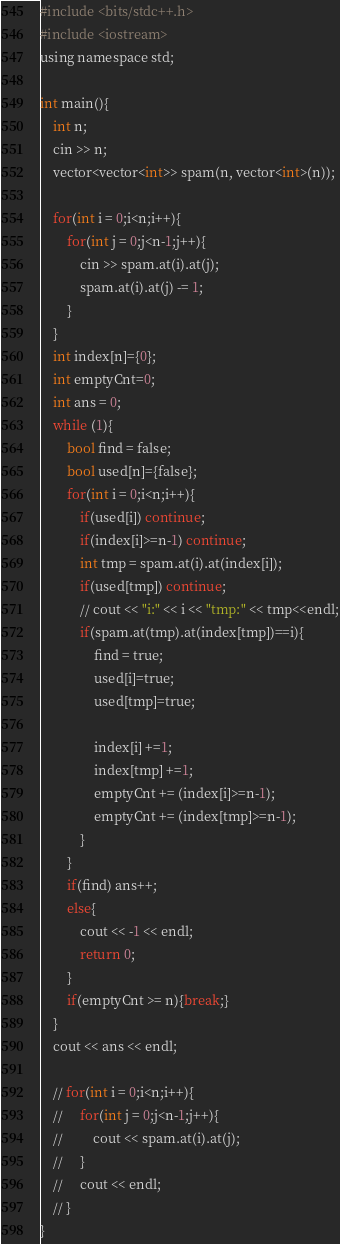<code> <loc_0><loc_0><loc_500><loc_500><_Python_>#include <bits/stdc++.h>
#include <iostream>
using namespace std;

int main(){
    int n;
    cin >> n;
    vector<vector<int>> spam(n, vector<int>(n));

    for(int i = 0;i<n;i++){
        for(int j = 0;j<n-1;j++){
            cin >> spam.at(i).at(j);
            spam.at(i).at(j) -= 1;
        }
    }
    int index[n]={0};
    int emptyCnt=0;
    int ans = 0;
    while (1){
        bool find = false;
        bool used[n]={false};
        for(int i = 0;i<n;i++){
            if(used[i]) continue;
            if(index[i]>=n-1) continue;
            int tmp = spam.at(i).at(index[i]);
            if(used[tmp]) continue; 
            // cout << "i:" << i << "tmp:" << tmp<<endl;
            if(spam.at(tmp).at(index[tmp])==i){
                find = true;
                used[i]=true;
                used[tmp]=true;
                
                index[i] +=1;
                index[tmp] +=1;
                emptyCnt += (index[i]>=n-1);
                emptyCnt += (index[tmp]>=n-1);
            }
        }
        if(find) ans++;
        else{
            cout << -1 << endl;
            return 0;
        }
        if(emptyCnt >= n){break;}
    }
    cout << ans << endl;
    
    // for(int i = 0;i<n;i++){
    //     for(int j = 0;j<n-1;j++){
    //         cout << spam.at(i).at(j);
    //     }
    //     cout << endl;
    // }
} </code> 